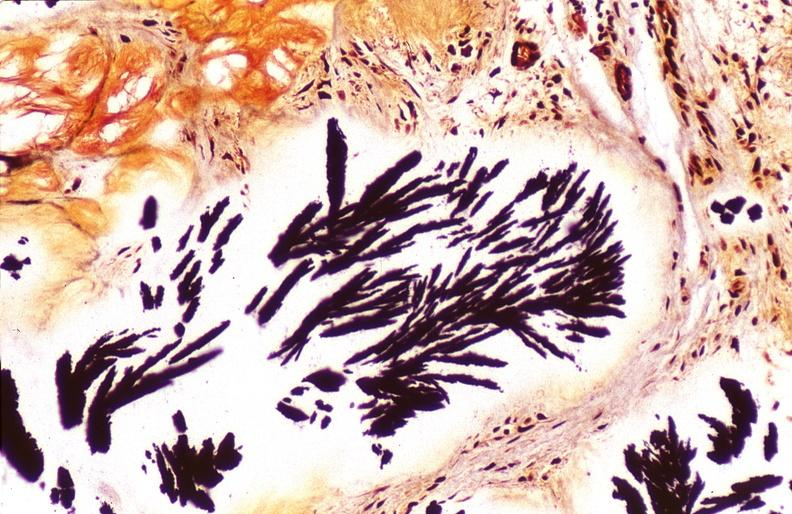s fibrosis mumps present?
Answer the question using a single word or phrase. No 